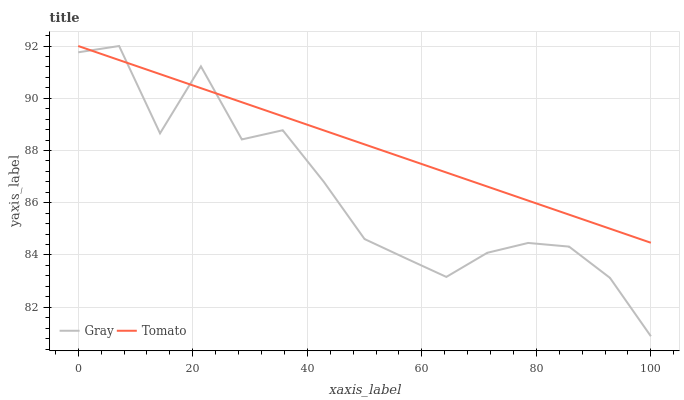Does Gray have the maximum area under the curve?
Answer yes or no. No. Is Gray the smoothest?
Answer yes or no. No. 